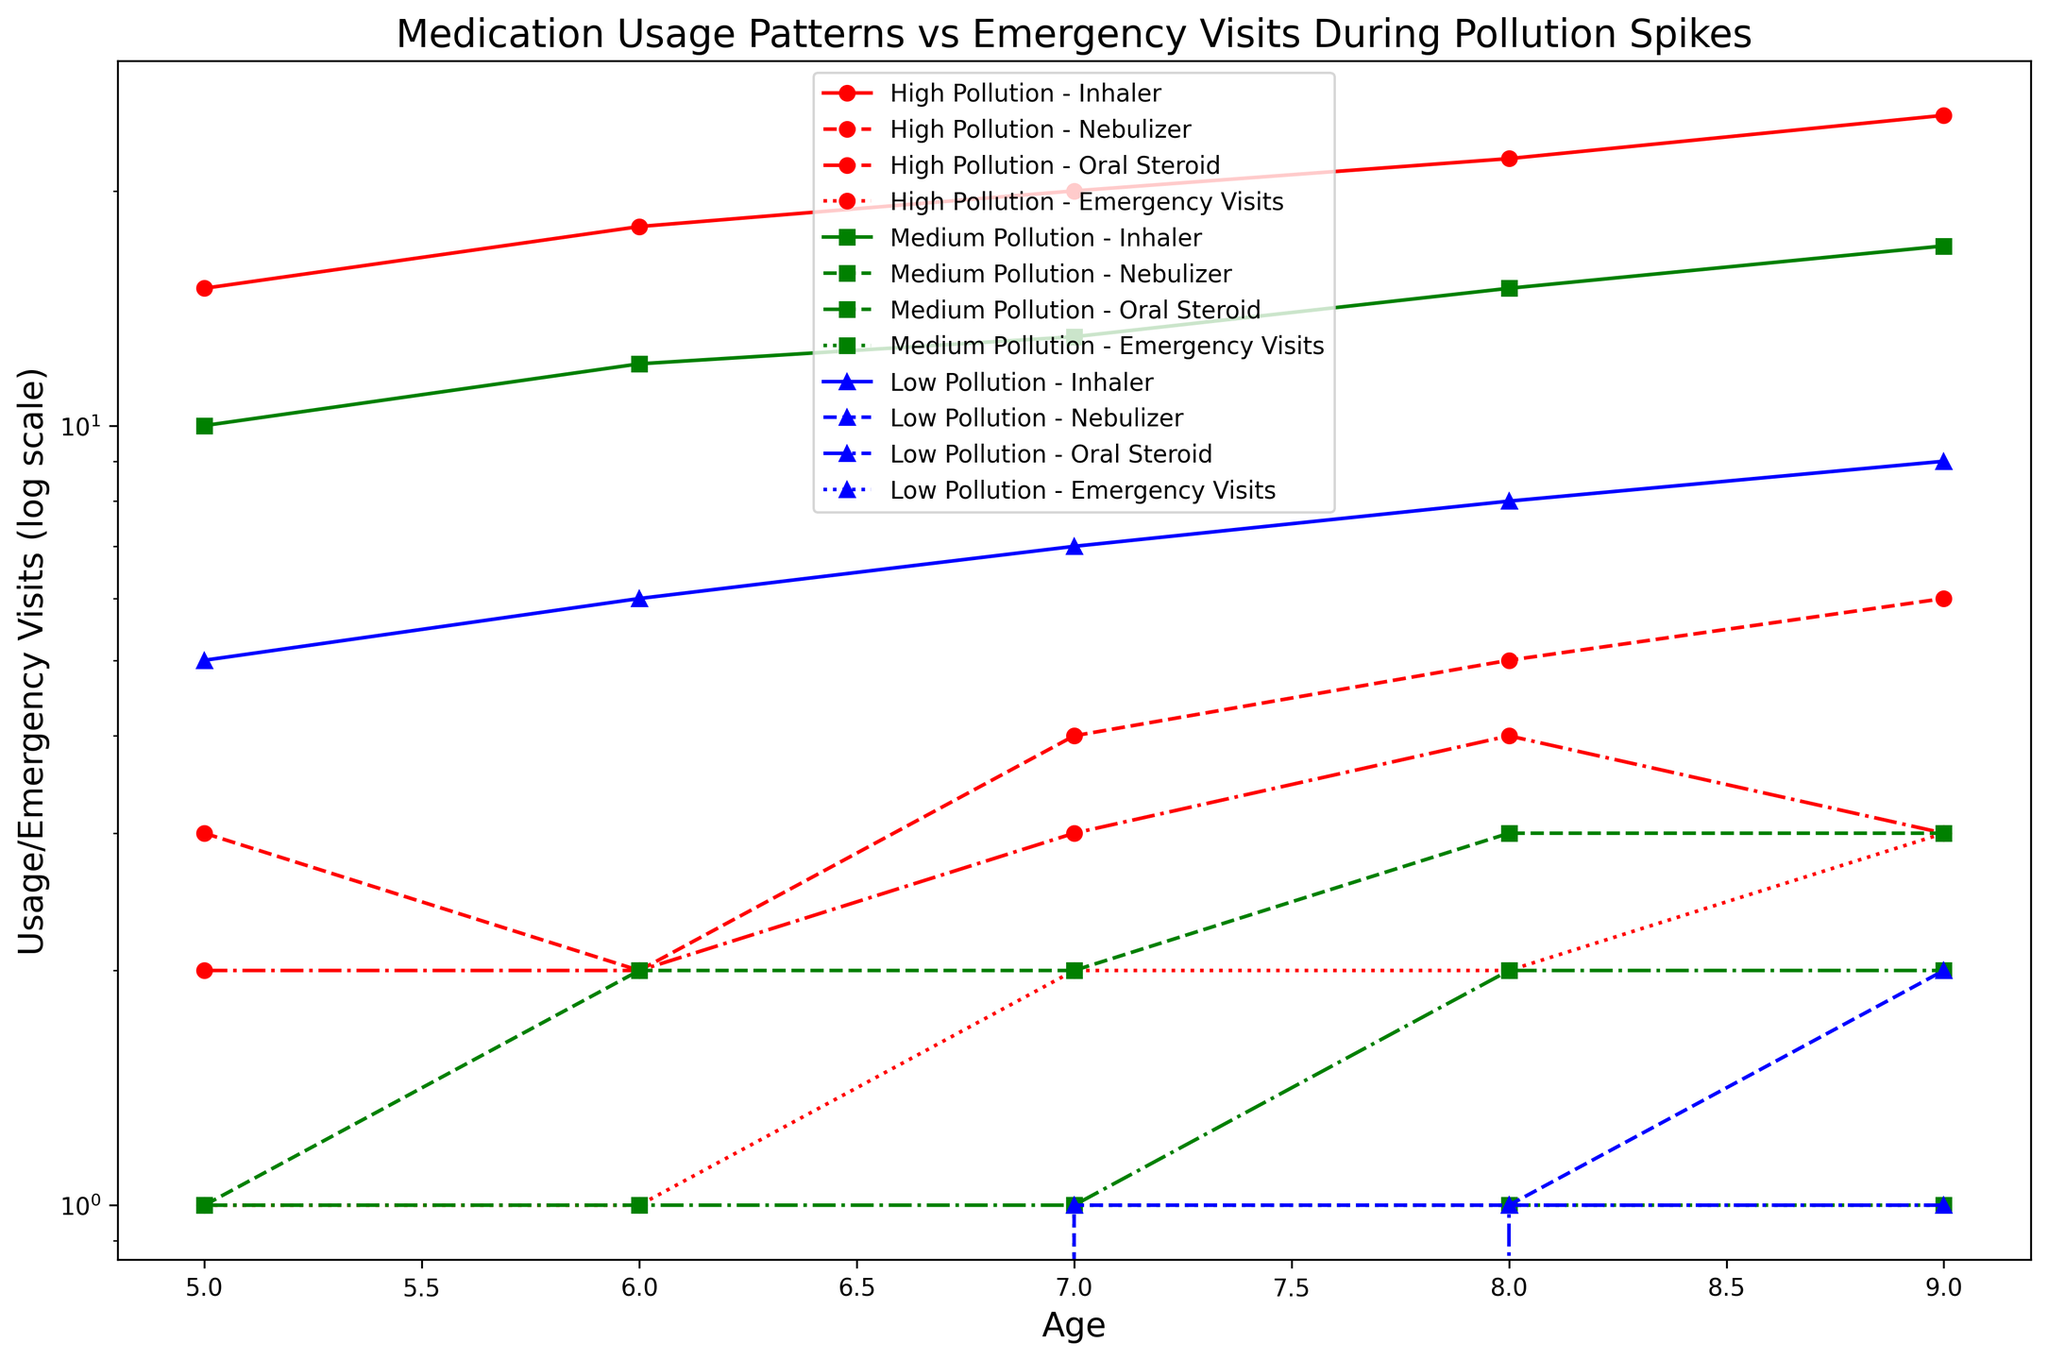what color represents high pollution levels? The plot uses different colors to represent different pollution levels. Red is used to denote high pollution levels.
Answer: Red how many emergency visits are recorded for 9-year-olds during high pollution? Look for the data points corresponding to 9-year-olds and high pollution. The plot shows 3 emergency visits at age 9 for high pollution.
Answer: 3 compare inhaler uses between medium and low pollution levels for 8-year-olds Find the data points for 8-year-olds and check the inhaler uses for both medium and low pollution levels. For medium pollution, it's 15; for low pollution, it's 8.
Answer: Medium pollution has 7 more uses than low pollution which age group has the highest number of oral steroid uses during low pollution levels? Examine the data points for oral steroid uses in low pollution across different ages. The highest value is for 8-year-olds with 1 use.
Answer: 8-year-olds what happens to the number of nebulizer uses as age increases under high pollution conditions? Track the trend of nebulizer uses under high pollution as age increases from 5 to 9. It consistently increases from 3 to 6 uses.
Answer: It increases how does the number of oral steroid uses at age 7 compare across different pollution levels? Review the graph for oral steroid uses at age 7 across different pollution levels: 3 uses for high, 1 for medium, and 0 for low pollution.
Answer: High pollution has the most; low pollution has the least which line style represents emergency visits in the plot? Identify the line styles used to represent different parameters in the plot. Dotted lines are used for emergency visits.
Answer: Dotted what is the difference in inhaler uses between ages 5 and 9 during low pollution periods? Calculate the difference in inhaler uses at ages 5 and 9 during low pollution periods. Age 5 has 5 uses, and age 9 has 9 uses. The difference is 9 - 5.
Answer: 4 how do emergency visits vary with age during high pollution levels? Observe the changes in emergency visits with age during high pollution levels. They increase from 1 to 3 as age progresses from 5 to 9.
Answer: Increase which pollution level shows the biggest increase in nebulizer uses from age 5 to age 6? Compare the increase in nebulizer uses from age 5 to age 6 for all pollution levels. High pollution shows no change (3 to 2), Medium has an increase from 1 to 2, and Low has no use at both ages.
Answer: Medium pollution 